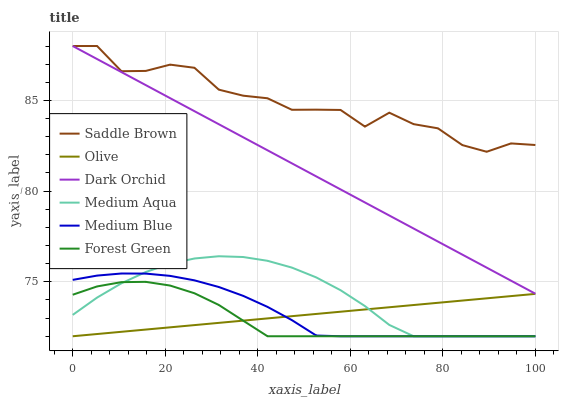Does Dark Orchid have the minimum area under the curve?
Answer yes or no. No. Does Dark Orchid have the maximum area under the curve?
Answer yes or no. No. Is Dark Orchid the smoothest?
Answer yes or no. No. Is Dark Orchid the roughest?
Answer yes or no. No. Does Dark Orchid have the lowest value?
Answer yes or no. No. Does Forest Green have the highest value?
Answer yes or no. No. Is Medium Blue less than Saddle Brown?
Answer yes or no. Yes. Is Dark Orchid greater than Olive?
Answer yes or no. Yes. Does Medium Blue intersect Saddle Brown?
Answer yes or no. No. 